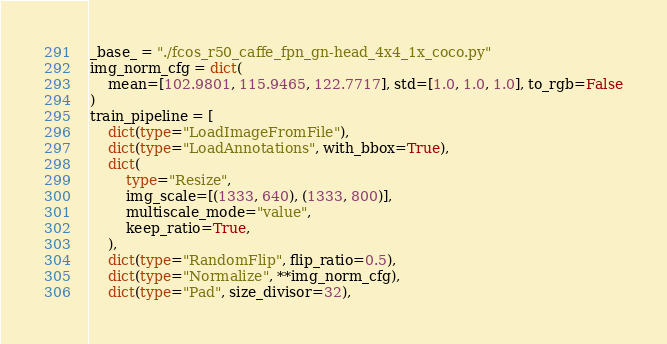<code> <loc_0><loc_0><loc_500><loc_500><_Python_>_base_ = "./fcos_r50_caffe_fpn_gn-head_4x4_1x_coco.py"
img_norm_cfg = dict(
    mean=[102.9801, 115.9465, 122.7717], std=[1.0, 1.0, 1.0], to_rgb=False
)
train_pipeline = [
    dict(type="LoadImageFromFile"),
    dict(type="LoadAnnotations", with_bbox=True),
    dict(
        type="Resize",
        img_scale=[(1333, 640), (1333, 800)],
        multiscale_mode="value",
        keep_ratio=True,
    ),
    dict(type="RandomFlip", flip_ratio=0.5),
    dict(type="Normalize", **img_norm_cfg),
    dict(type="Pad", size_divisor=32),</code> 